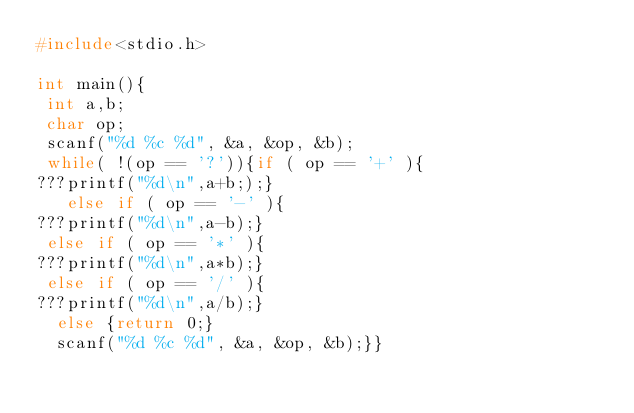Convert code to text. <code><loc_0><loc_0><loc_500><loc_500><_C_>#include<stdio.h>

int main(){
 int a,b;
 char op;
 scanf("%d %c %d", &a, &op, &b);
 while( !(op == '?')){if ( op == '+' ){
???printf("%d\n",a+b;);}
   else if ( op == '-' ){
???printf("%d\n",a-b);}
 else if ( op == '*' ){
???printf("%d\n",a*b);}
 else if ( op == '/' ){
???printf("%d\n",a/b);} 
  else {return 0;}
  scanf("%d %c %d", &a, &op, &b);}}</code> 